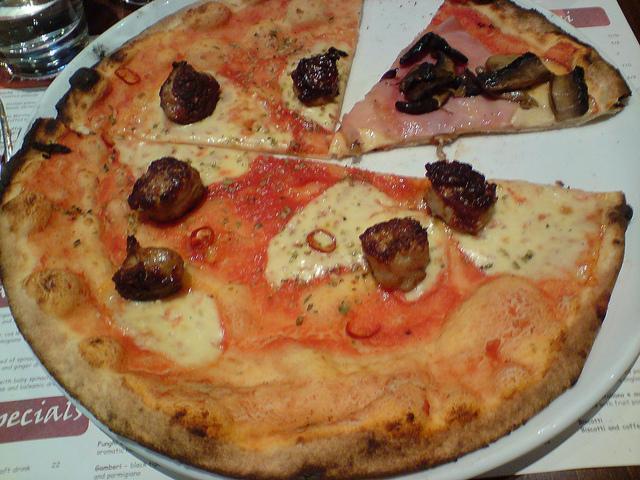How many slices is this pizza divided into?
Give a very brief answer. 3. How many slices are missing?
Give a very brief answer. 1. How many pizzas are visible?
Give a very brief answer. 3. 